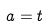Convert formula to latex. <formula><loc_0><loc_0><loc_500><loc_500>a = t</formula> 